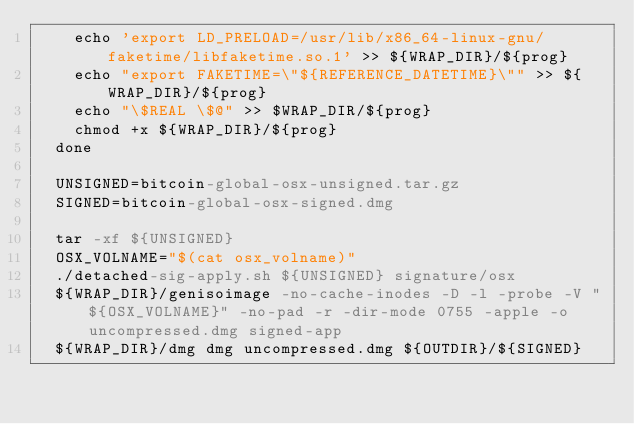Convert code to text. <code><loc_0><loc_0><loc_500><loc_500><_YAML_>    echo 'export LD_PRELOAD=/usr/lib/x86_64-linux-gnu/faketime/libfaketime.so.1' >> ${WRAP_DIR}/${prog}
    echo "export FAKETIME=\"${REFERENCE_DATETIME}\"" >> ${WRAP_DIR}/${prog}
    echo "\$REAL \$@" >> $WRAP_DIR/${prog}
    chmod +x ${WRAP_DIR}/${prog}
  done

  UNSIGNED=bitcoin-global-osx-unsigned.tar.gz
  SIGNED=bitcoin-global-osx-signed.dmg

  tar -xf ${UNSIGNED}
  OSX_VOLNAME="$(cat osx_volname)"
  ./detached-sig-apply.sh ${UNSIGNED} signature/osx
  ${WRAP_DIR}/genisoimage -no-cache-inodes -D -l -probe -V "${OSX_VOLNAME}" -no-pad -r -dir-mode 0755 -apple -o uncompressed.dmg signed-app
  ${WRAP_DIR}/dmg dmg uncompressed.dmg ${OUTDIR}/${SIGNED}
</code> 